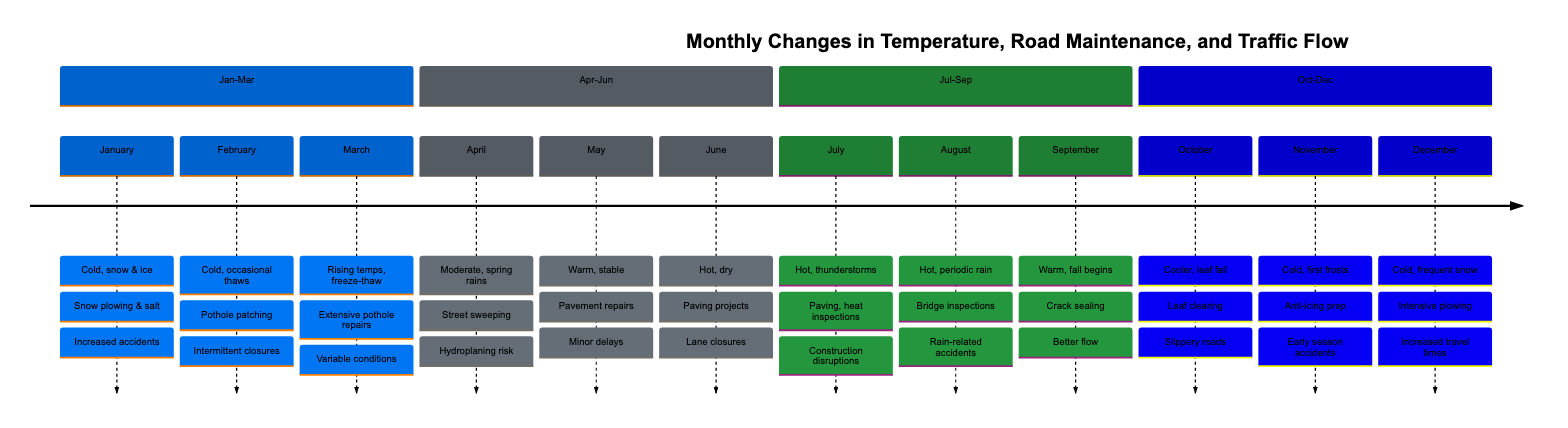What temperature trend is observed in March? In March, the timeline indicates "Rising temperatures, freeze-thaw cycles" as the temperature trend. This is explicitly stated in the diagram.
Answer: Rising temperatures, freeze-thaw cycles What road maintenance activities are ongoing in June? The activities for June are listed as "Paving and resurfacing projects." This can be found in the section for June on the diagram.
Answer: Paving and resurfacing projects How does July's weather influence traffic conditions? In July, the weather is described as "Hot temperatures, occasional thunderstorms," which leads to "Traffic disruptions from construction, storm-related slowdowns." Therefore, the weather has an impact by causing traffic disruptions.
Answer: Traffic disruptions from construction, storm-related slowdowns What is the risk mentioned for April? The risk for April relates to potentially hazardous driving conditions due to "Hydroplaning, reduced visibility." This is a direct consequence of the described weather conditions in April.
Answer: Hydroplaning, reduced visibility Which month has the highest likelihood of accidents due to the weather? The month with the highest likelihood of accidents due to the weather is December, as it describes "Increased travel times, higher accident rates" caused by "Cold temperatures, frequent snow." Therefore, December is the answer.
Answer: December During which month is pothole patching mentioned? Pothole patching is mentioned in the timeline for February. The specific text states "Pothole patching, continued snow and ice management." This indicates that February has pothole patching activities.
Answer: February What maintenance activity is associated with October? The maintenance activity for October is "Clearing fallen leaves, winter preparation." This is noted in the October section of the diagram.
Answer: Clearing fallen leaves, winter preparation How many months in the timeline are categorized under "Hot temperatures"? The months categorized as having "Hot temperatures" are June, July, and August, totaling three months. This can be counted directly from the diagram sections.
Answer: Three 